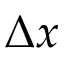<formula> <loc_0><loc_0><loc_500><loc_500>\Delta x</formula> 